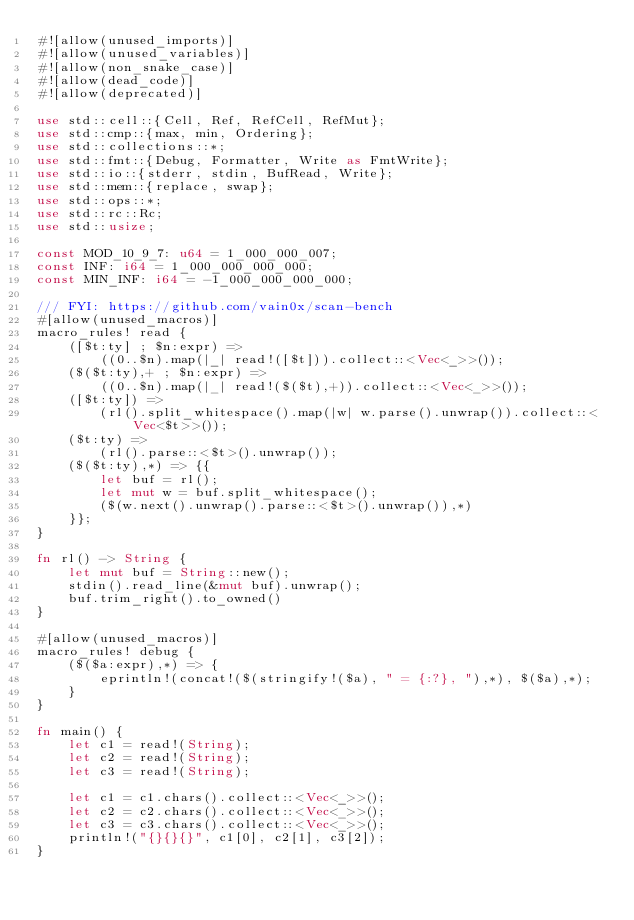<code> <loc_0><loc_0><loc_500><loc_500><_Rust_>#![allow(unused_imports)]
#![allow(unused_variables)]
#![allow(non_snake_case)]
#![allow(dead_code)]
#![allow(deprecated)]

use std::cell::{Cell, Ref, RefCell, RefMut};
use std::cmp::{max, min, Ordering};
use std::collections::*;
use std::fmt::{Debug, Formatter, Write as FmtWrite};
use std::io::{stderr, stdin, BufRead, Write};
use std::mem::{replace, swap};
use std::ops::*;
use std::rc::Rc;
use std::usize;

const MOD_10_9_7: u64 = 1_000_000_007;
const INF: i64 = 1_000_000_000_000;
const MIN_INF: i64 = -1_000_000_000_000;

/// FYI: https://github.com/vain0x/scan-bench
#[allow(unused_macros)]
macro_rules! read {
    ([$t:ty] ; $n:expr) =>
        ((0..$n).map(|_| read!([$t])).collect::<Vec<_>>());
    ($($t:ty),+ ; $n:expr) =>
        ((0..$n).map(|_| read!($($t),+)).collect::<Vec<_>>());
    ([$t:ty]) =>
        (rl().split_whitespace().map(|w| w.parse().unwrap()).collect::<Vec<$t>>());
    ($t:ty) =>
        (rl().parse::<$t>().unwrap());
    ($($t:ty),*) => {{
        let buf = rl();
        let mut w = buf.split_whitespace();
        ($(w.next().unwrap().parse::<$t>().unwrap()),*)
    }};
}

fn rl() -> String {
    let mut buf = String::new();
    stdin().read_line(&mut buf).unwrap();
    buf.trim_right().to_owned()
}

#[allow(unused_macros)]
macro_rules! debug {
    ($($a:expr),*) => {
        eprintln!(concat!($(stringify!($a), " = {:?}, "),*), $($a),*);
    }
}

fn main() {
    let c1 = read!(String);
    let c2 = read!(String);
    let c3 = read!(String);

    let c1 = c1.chars().collect::<Vec<_>>();
    let c2 = c2.chars().collect::<Vec<_>>();
    let c3 = c3.chars().collect::<Vec<_>>();
    println!("{}{}{}", c1[0], c2[1], c3[2]);
}
</code> 